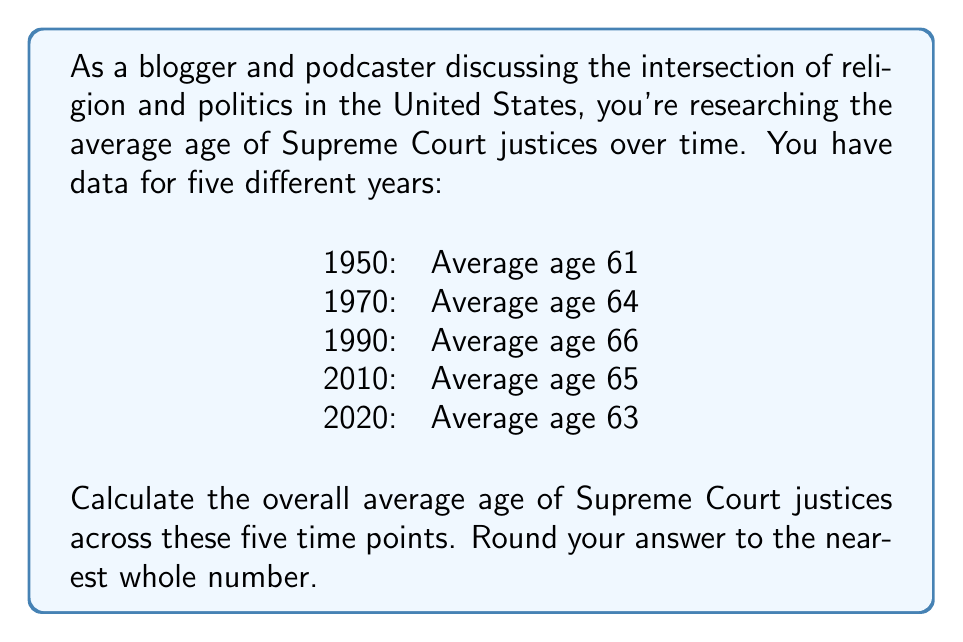Give your solution to this math problem. To find the overall average age of Supreme Court justices across these five time points, we need to:

1. Add up all the average ages
2. Divide the sum by the number of time points

Let's break it down step-by-step:

1. Sum of average ages:
   $$61 + 64 + 66 + 65 + 63 = 319$$

2. Number of time points: 5

3. Calculate the average:
   $$\text{Average} = \frac{\text{Sum of values}}{\text{Number of values}}$$
   $$\text{Average} = \frac{319}{5} = 63.8$$

4. Round to the nearest whole number:
   63.8 rounds up to 64

Therefore, the overall average age of Supreme Court justices across these five time points, rounded to the nearest whole number, is 64 years.
Answer: 64 years 